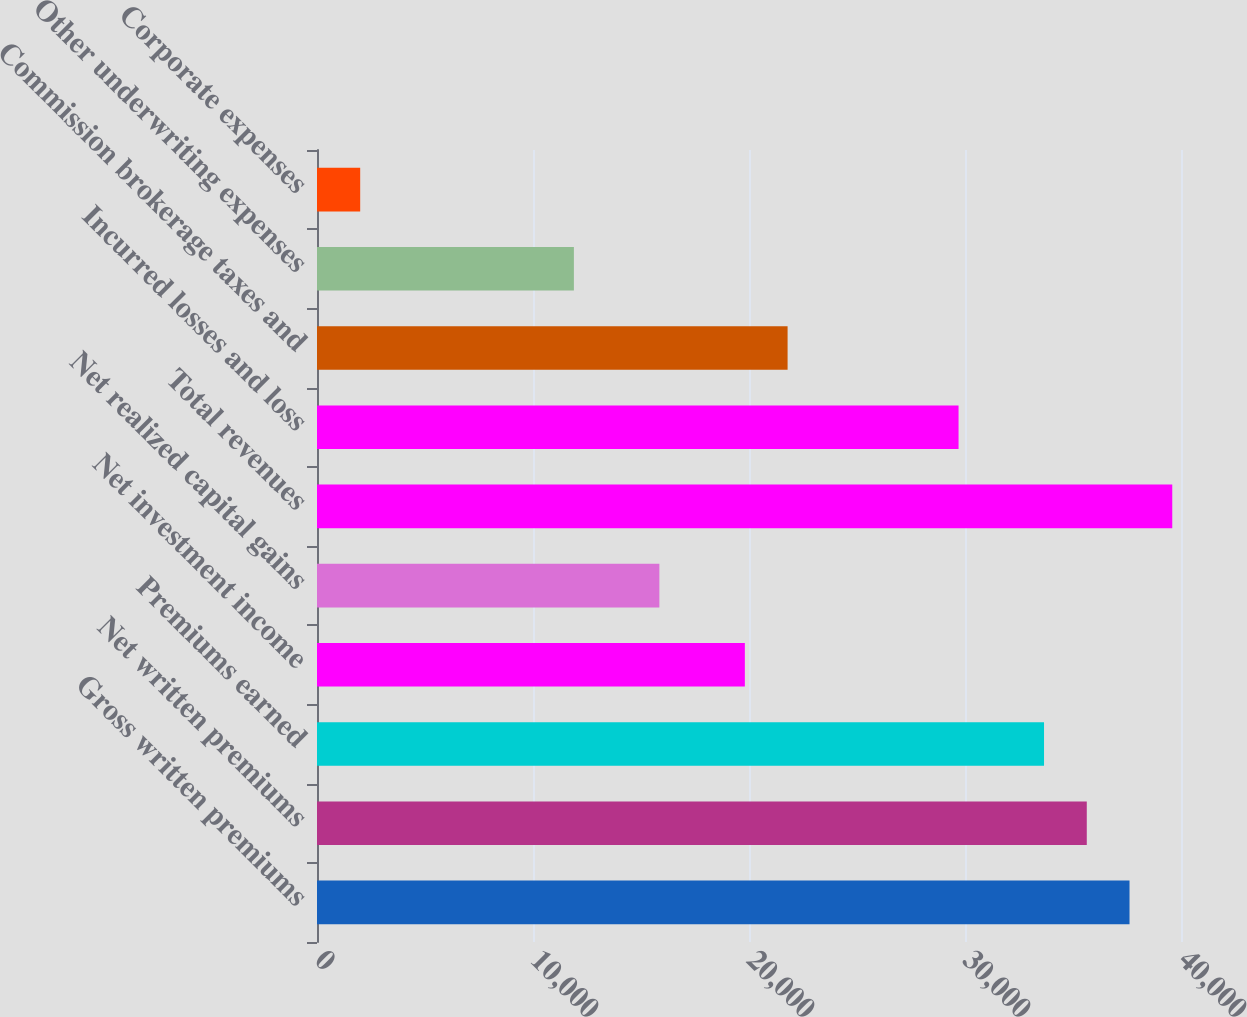Convert chart. <chart><loc_0><loc_0><loc_500><loc_500><bar_chart><fcel>Gross written premiums<fcel>Net written premiums<fcel>Premiums earned<fcel>Net investment income<fcel>Net realized capital gains<fcel>Total revenues<fcel>Incurred losses and loss<fcel>Commission brokerage taxes and<fcel>Other underwriting expenses<fcel>Corporate expenses<nl><fcel>37616.7<fcel>35637.9<fcel>33659.2<fcel>19808<fcel>15850.5<fcel>39595.4<fcel>29701.7<fcel>21786.7<fcel>11893<fcel>1999.34<nl></chart> 